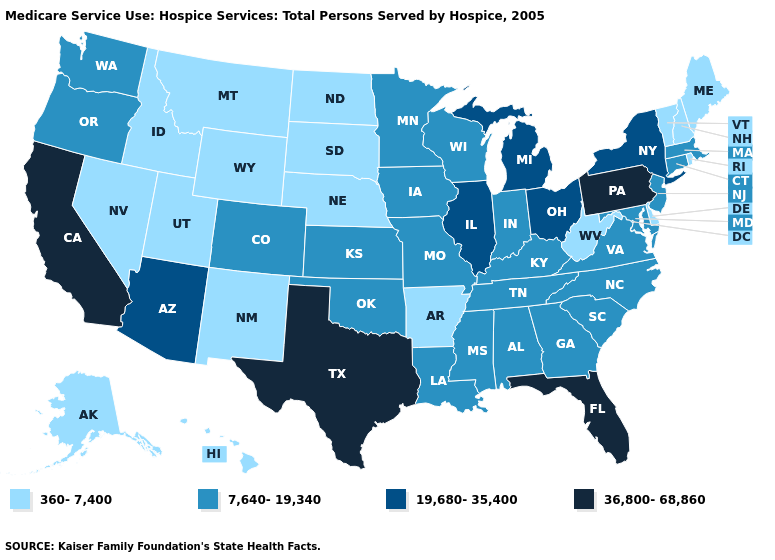Which states hav the highest value in the MidWest?
Quick response, please. Illinois, Michigan, Ohio. What is the lowest value in states that border Texas?
Be succinct. 360-7,400. What is the value of West Virginia?
Keep it brief. 360-7,400. Does Colorado have the same value as Utah?
Short answer required. No. Among the states that border Connecticut , which have the highest value?
Write a very short answer. New York. Does the map have missing data?
Keep it brief. No. Name the states that have a value in the range 19,680-35,400?
Keep it brief. Arizona, Illinois, Michigan, New York, Ohio. What is the value of North Dakota?
Quick response, please. 360-7,400. Does California have the highest value in the USA?
Give a very brief answer. Yes. Among the states that border Pennsylvania , does Ohio have the lowest value?
Short answer required. No. What is the highest value in the USA?
Be succinct. 36,800-68,860. Is the legend a continuous bar?
Concise answer only. No. Among the states that border Arizona , does Colorado have the lowest value?
Short answer required. No. Is the legend a continuous bar?
Give a very brief answer. No. 